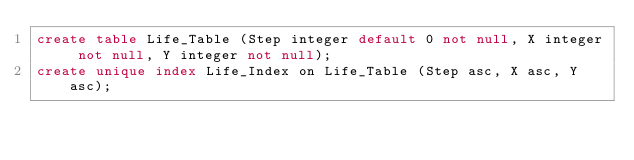Convert code to text. <code><loc_0><loc_0><loc_500><loc_500><_SQL_>create table Life_Table (Step integer default 0 not null, X integer not null, Y integer not null);
create unique index Life_Index on Life_Table (Step asc, X asc, Y asc);
</code> 